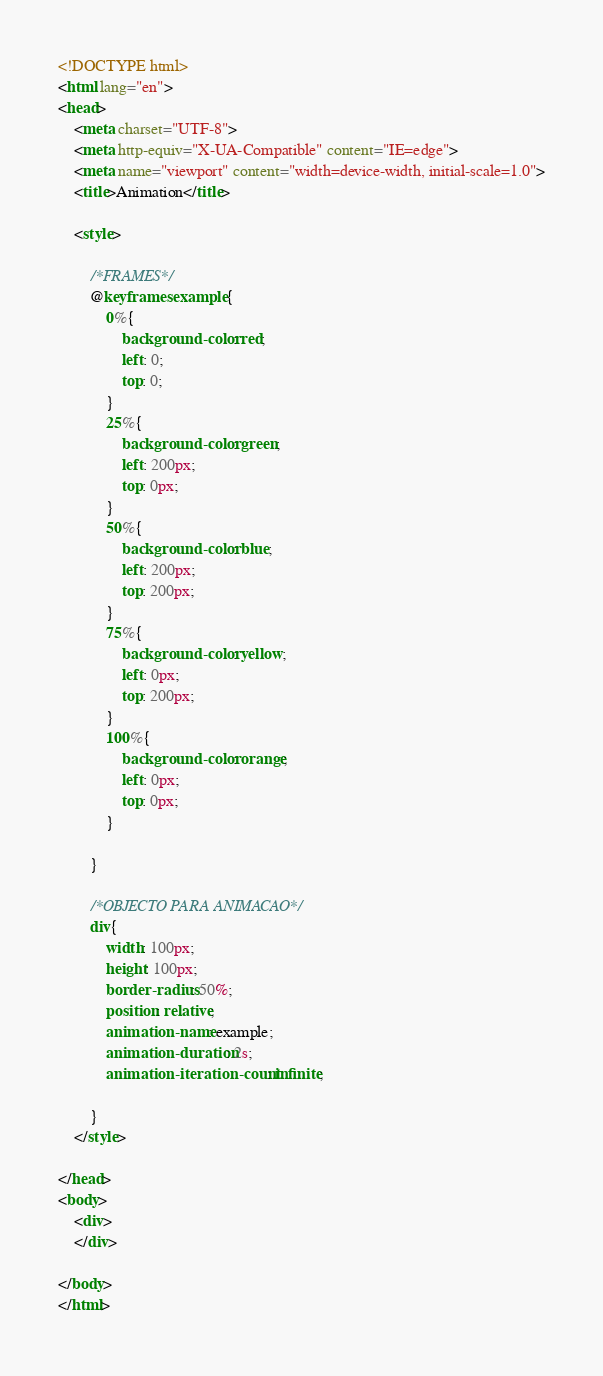Convert code to text. <code><loc_0><loc_0><loc_500><loc_500><_HTML_><!DOCTYPE html>
<html lang="en">
<head>
    <meta charset="UTF-8">
    <meta http-equiv="X-UA-Compatible" content="IE=edge">
    <meta name="viewport" content="width=device-width, initial-scale=1.0">
    <title>Animation</title>

    <style>

        /*FRAMES*/
        @keyframes example{
            0%{
                background-color: red;
                left: 0;
                top: 0;
            }
            25%{
                background-color: green;
                left: 200px;
                top: 0px;
            }
            50%{
                background-color: blue;
                left: 200px;
                top: 200px;
            }
            75%{
                background-color: yellow;
                left: 0px;
                top: 200px;
            }
            100%{
                background-color: orange;
                left: 0px;
                top: 0px;
            }

        }

        /*OBJECTO PARA ANIMACAO*/
        div{
            width: 100px;
            height: 100px;
            border-radius: 50%;
            position: relative;
            animation-name: example;
            animation-duration: 2s;
            animation-iteration-count: infinite;
            
        }
    </style>

</head>
<body>
    <div>
    </div>
    
</body>
</html></code> 